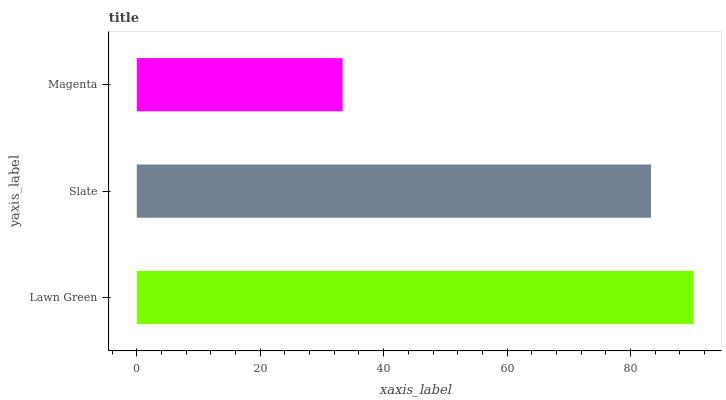Is Magenta the minimum?
Answer yes or no. Yes. Is Lawn Green the maximum?
Answer yes or no. Yes. Is Slate the minimum?
Answer yes or no. No. Is Slate the maximum?
Answer yes or no. No. Is Lawn Green greater than Slate?
Answer yes or no. Yes. Is Slate less than Lawn Green?
Answer yes or no. Yes. Is Slate greater than Lawn Green?
Answer yes or no. No. Is Lawn Green less than Slate?
Answer yes or no. No. Is Slate the high median?
Answer yes or no. Yes. Is Slate the low median?
Answer yes or no. Yes. Is Magenta the high median?
Answer yes or no. No. Is Magenta the low median?
Answer yes or no. No. 